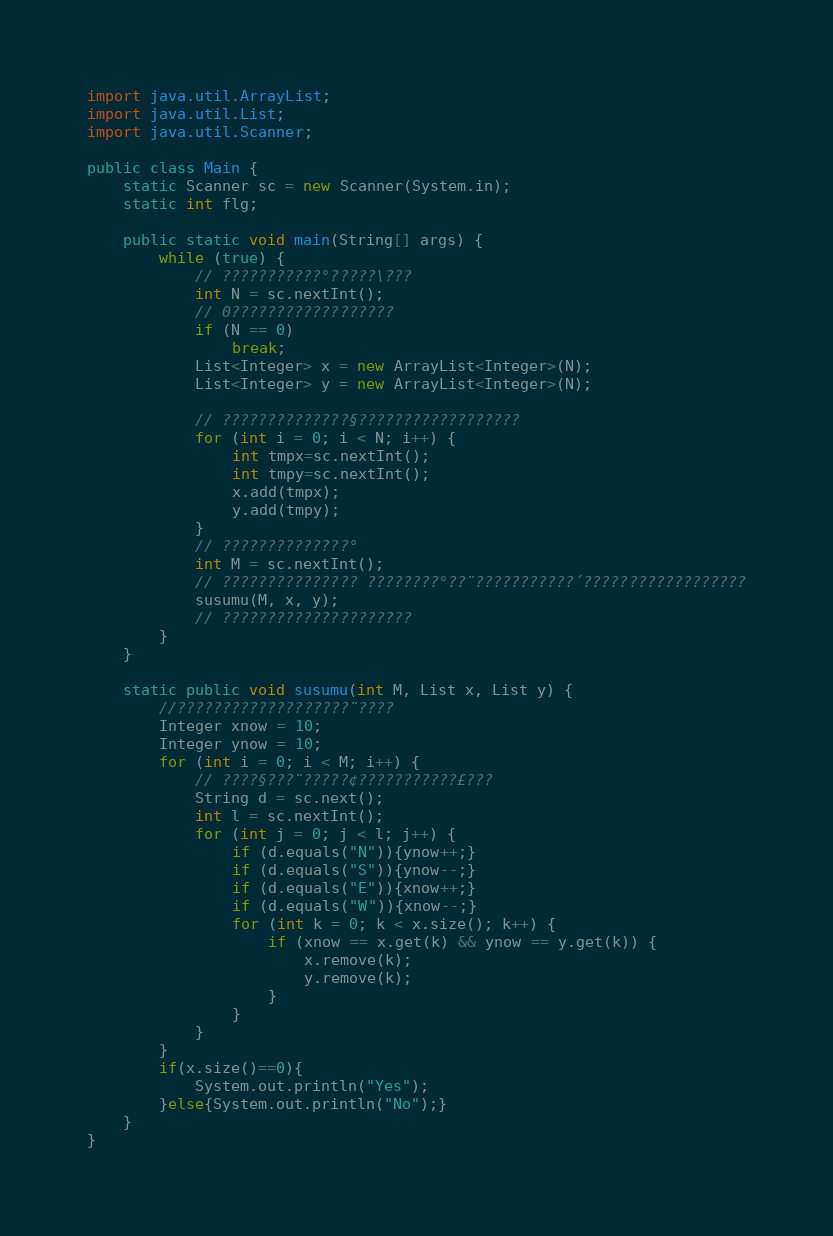Convert code to text. <code><loc_0><loc_0><loc_500><loc_500><_Java_>
import java.util.ArrayList;
import java.util.List;
import java.util.Scanner;

public class Main {
    static Scanner sc = new Scanner(System.in);
    static int flg;

    public static void main(String[] args) {
        while (true) {
            // ???????????°?????\???
            int N = sc.nextInt();
            // 0??????????????????
            if (N == 0)
                break;
            List<Integer> x = new ArrayList<Integer>(N);
            List<Integer> y = new ArrayList<Integer>(N);

            // ??????????????§??????????????????
            for (int i = 0; i < N; i++) {
                int tmpx=sc.nextInt();
                int tmpy=sc.nextInt();
            	x.add(tmpx);
                y.add(tmpy);
            }
            // ??????????????°
            int M = sc.nextInt();
            // ??????????????? ????????°??¨???????????´??????????????????
            susumu(M, x, y);
            // ?????????????????????
        }
    }

    static public void susumu(int M, List x, List y) {
        //???????????????????¨????
        Integer xnow = 10;
        Integer ynow = 10;
        for (int i = 0; i < M; i++) {
            // ????§???¨?????¢???????????£???
            String d = sc.next();
            int l = sc.nextInt();
            for (int j = 0; j < l; j++) {
                if (d.equals("N")){ynow++;}
                if (d.equals("S")){ynow--;}
                if (d.equals("E")){xnow++;}
                if (d.equals("W")){xnow--;}
                for (int k = 0; k < x.size(); k++) {
                    if (xnow == x.get(k) && ynow == y.get(k)) {
                        x.remove(k);
                        y.remove(k);
                    }
                }
            }
        }
        if(x.size()==0){
            System.out.println("Yes");
        }else{System.out.println("No");}
    }
}</code> 